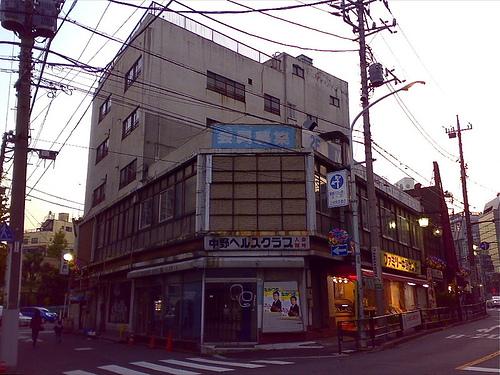Are the signs in English?
Concise answer only. No. Are there lots of electrical wires?
Give a very brief answer. Yes. How many windows are on the side of the building?
Write a very short answer. 6. 